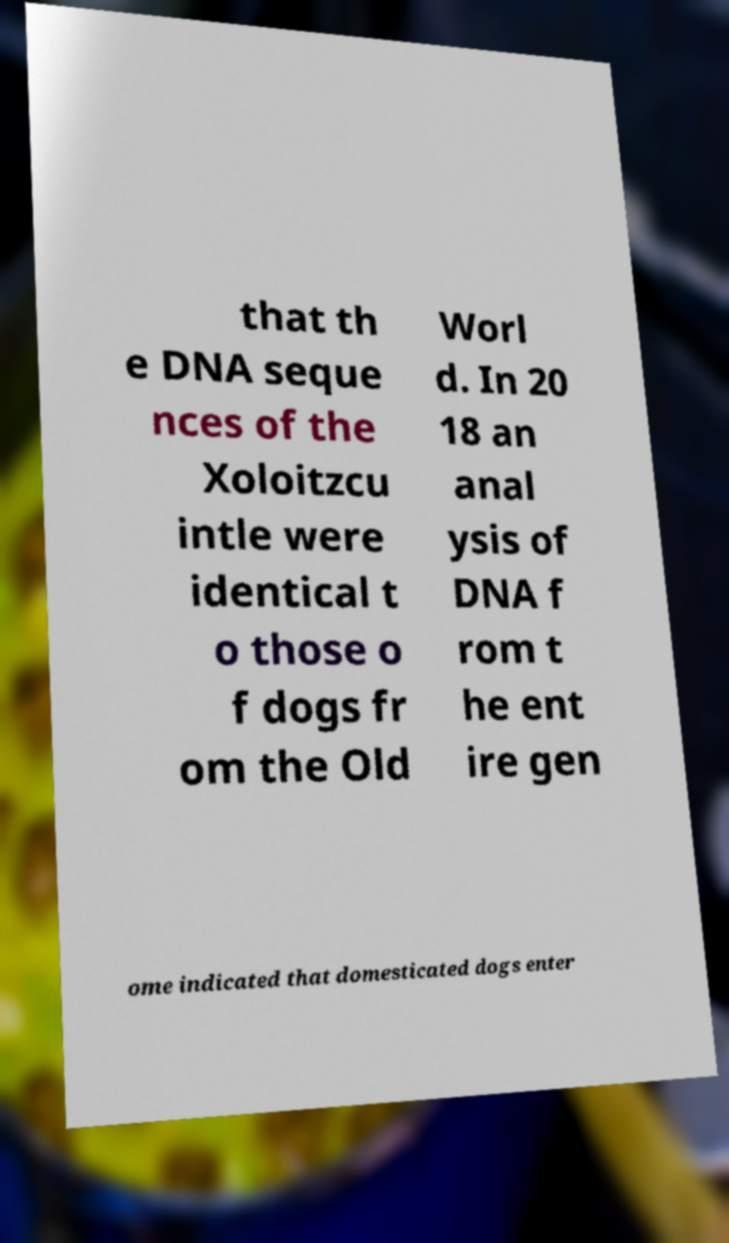I need the written content from this picture converted into text. Can you do that? that th e DNA seque nces of the Xoloitzcu intle were identical t o those o f dogs fr om the Old Worl d. In 20 18 an anal ysis of DNA f rom t he ent ire gen ome indicated that domesticated dogs enter 